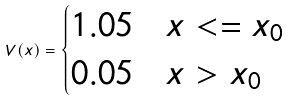<formula> <loc_0><loc_0><loc_500><loc_500>V ( x ) = \begin{cases} 1 . 0 5 & x < = x _ { 0 } \\ 0 . 0 5 & x > x _ { 0 } \\ \end{cases}</formula> 